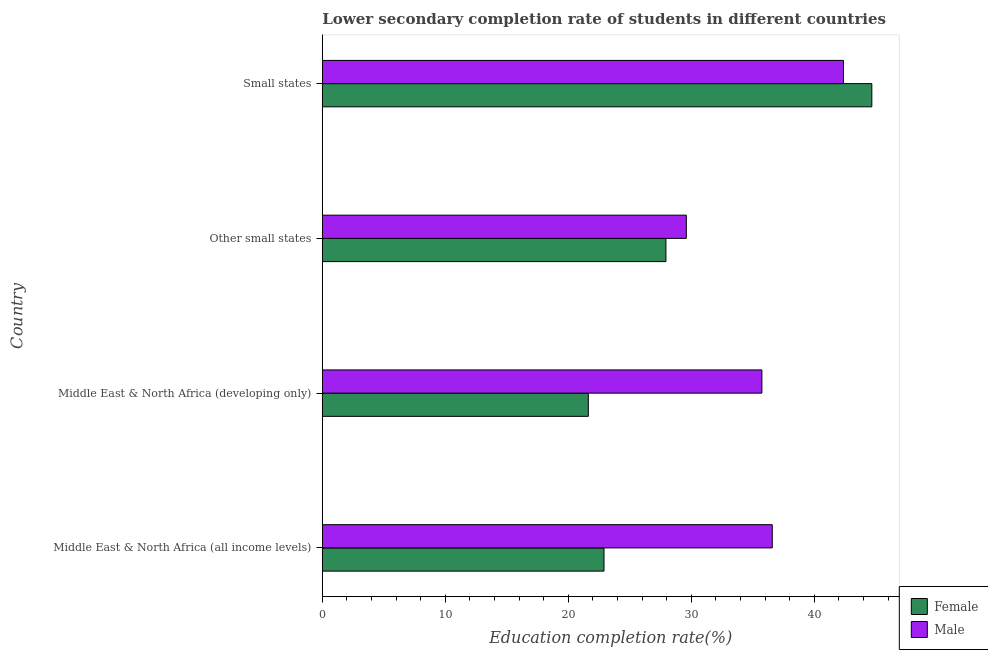Are the number of bars per tick equal to the number of legend labels?
Provide a succinct answer. Yes. How many bars are there on the 2nd tick from the top?
Provide a succinct answer. 2. How many bars are there on the 3rd tick from the bottom?
Your response must be concise. 2. What is the label of the 3rd group of bars from the top?
Keep it short and to the point. Middle East & North Africa (developing only). In how many cases, is the number of bars for a given country not equal to the number of legend labels?
Offer a terse response. 0. What is the education completion rate of male students in Middle East & North Africa (developing only)?
Make the answer very short. 35.74. Across all countries, what is the maximum education completion rate of male students?
Your answer should be very brief. 42.37. Across all countries, what is the minimum education completion rate of female students?
Offer a terse response. 21.63. In which country was the education completion rate of female students maximum?
Keep it short and to the point. Small states. In which country was the education completion rate of female students minimum?
Your answer should be compact. Middle East & North Africa (developing only). What is the total education completion rate of female students in the graph?
Your response must be concise. 117.14. What is the difference between the education completion rate of male students in Middle East & North Africa (developing only) and that in Other small states?
Ensure brevity in your answer.  6.14. What is the difference between the education completion rate of female students in Middle East & North Africa (developing only) and the education completion rate of male students in Other small states?
Your answer should be very brief. -7.97. What is the average education completion rate of male students per country?
Your response must be concise. 36.07. What is the difference between the education completion rate of female students and education completion rate of male students in Small states?
Provide a short and direct response. 2.31. In how many countries, is the education completion rate of male students greater than 44 %?
Ensure brevity in your answer.  0. What is the ratio of the education completion rate of male students in Middle East & North Africa (developing only) to that in Small states?
Your answer should be very brief. 0.84. Is the education completion rate of female students in Middle East & North Africa (developing only) less than that in Other small states?
Your answer should be very brief. Yes. What is the difference between the highest and the second highest education completion rate of female students?
Make the answer very short. 16.74. What is the difference between the highest and the lowest education completion rate of female students?
Keep it short and to the point. 23.05. In how many countries, is the education completion rate of male students greater than the average education completion rate of male students taken over all countries?
Ensure brevity in your answer.  2. Is the sum of the education completion rate of male students in Other small states and Small states greater than the maximum education completion rate of female students across all countries?
Make the answer very short. Yes. Are all the bars in the graph horizontal?
Provide a short and direct response. Yes. What is the difference between two consecutive major ticks on the X-axis?
Your answer should be compact. 10. Are the values on the major ticks of X-axis written in scientific E-notation?
Your answer should be compact. No. Where does the legend appear in the graph?
Give a very brief answer. Bottom right. What is the title of the graph?
Offer a terse response. Lower secondary completion rate of students in different countries. Does "Foreign liabilities" appear as one of the legend labels in the graph?
Keep it short and to the point. No. What is the label or title of the X-axis?
Provide a succinct answer. Education completion rate(%). What is the label or title of the Y-axis?
Offer a very short reply. Country. What is the Education completion rate(%) in Female in Middle East & North Africa (all income levels)?
Keep it short and to the point. 22.9. What is the Education completion rate(%) of Male in Middle East & North Africa (all income levels)?
Offer a very short reply. 36.58. What is the Education completion rate(%) in Female in Middle East & North Africa (developing only)?
Provide a short and direct response. 21.63. What is the Education completion rate(%) in Male in Middle East & North Africa (developing only)?
Offer a terse response. 35.74. What is the Education completion rate(%) in Female in Other small states?
Provide a succinct answer. 27.94. What is the Education completion rate(%) of Male in Other small states?
Offer a very short reply. 29.6. What is the Education completion rate(%) in Female in Small states?
Offer a very short reply. 44.68. What is the Education completion rate(%) of Male in Small states?
Your answer should be compact. 42.37. Across all countries, what is the maximum Education completion rate(%) of Female?
Offer a terse response. 44.68. Across all countries, what is the maximum Education completion rate(%) in Male?
Offer a terse response. 42.37. Across all countries, what is the minimum Education completion rate(%) of Female?
Your answer should be very brief. 21.63. Across all countries, what is the minimum Education completion rate(%) of Male?
Offer a terse response. 29.6. What is the total Education completion rate(%) of Female in the graph?
Your answer should be very brief. 117.14. What is the total Education completion rate(%) of Male in the graph?
Make the answer very short. 144.29. What is the difference between the Education completion rate(%) of Female in Middle East & North Africa (all income levels) and that in Middle East & North Africa (developing only)?
Make the answer very short. 1.28. What is the difference between the Education completion rate(%) in Male in Middle East & North Africa (all income levels) and that in Middle East & North Africa (developing only)?
Your response must be concise. 0.84. What is the difference between the Education completion rate(%) in Female in Middle East & North Africa (all income levels) and that in Other small states?
Your answer should be compact. -5.03. What is the difference between the Education completion rate(%) of Male in Middle East & North Africa (all income levels) and that in Other small states?
Your answer should be very brief. 6.99. What is the difference between the Education completion rate(%) of Female in Middle East & North Africa (all income levels) and that in Small states?
Your answer should be very brief. -21.77. What is the difference between the Education completion rate(%) of Male in Middle East & North Africa (all income levels) and that in Small states?
Make the answer very short. -5.79. What is the difference between the Education completion rate(%) in Female in Middle East & North Africa (developing only) and that in Other small states?
Your answer should be very brief. -6.31. What is the difference between the Education completion rate(%) in Male in Middle East & North Africa (developing only) and that in Other small states?
Offer a terse response. 6.14. What is the difference between the Education completion rate(%) in Female in Middle East & North Africa (developing only) and that in Small states?
Ensure brevity in your answer.  -23.05. What is the difference between the Education completion rate(%) in Male in Middle East & North Africa (developing only) and that in Small states?
Offer a very short reply. -6.63. What is the difference between the Education completion rate(%) of Female in Other small states and that in Small states?
Your answer should be compact. -16.74. What is the difference between the Education completion rate(%) in Male in Other small states and that in Small states?
Provide a succinct answer. -12.77. What is the difference between the Education completion rate(%) of Female in Middle East & North Africa (all income levels) and the Education completion rate(%) of Male in Middle East & North Africa (developing only)?
Provide a succinct answer. -12.84. What is the difference between the Education completion rate(%) in Female in Middle East & North Africa (all income levels) and the Education completion rate(%) in Male in Other small states?
Provide a succinct answer. -6.69. What is the difference between the Education completion rate(%) in Female in Middle East & North Africa (all income levels) and the Education completion rate(%) in Male in Small states?
Provide a succinct answer. -19.47. What is the difference between the Education completion rate(%) in Female in Middle East & North Africa (developing only) and the Education completion rate(%) in Male in Other small states?
Your answer should be very brief. -7.97. What is the difference between the Education completion rate(%) of Female in Middle East & North Africa (developing only) and the Education completion rate(%) of Male in Small states?
Provide a succinct answer. -20.74. What is the difference between the Education completion rate(%) in Female in Other small states and the Education completion rate(%) in Male in Small states?
Make the answer very short. -14.43. What is the average Education completion rate(%) in Female per country?
Your answer should be very brief. 29.28. What is the average Education completion rate(%) in Male per country?
Offer a very short reply. 36.07. What is the difference between the Education completion rate(%) of Female and Education completion rate(%) of Male in Middle East & North Africa (all income levels)?
Keep it short and to the point. -13.68. What is the difference between the Education completion rate(%) of Female and Education completion rate(%) of Male in Middle East & North Africa (developing only)?
Provide a succinct answer. -14.11. What is the difference between the Education completion rate(%) of Female and Education completion rate(%) of Male in Other small states?
Make the answer very short. -1.66. What is the difference between the Education completion rate(%) in Female and Education completion rate(%) in Male in Small states?
Your response must be concise. 2.31. What is the ratio of the Education completion rate(%) of Female in Middle East & North Africa (all income levels) to that in Middle East & North Africa (developing only)?
Provide a succinct answer. 1.06. What is the ratio of the Education completion rate(%) of Male in Middle East & North Africa (all income levels) to that in Middle East & North Africa (developing only)?
Provide a short and direct response. 1.02. What is the ratio of the Education completion rate(%) of Female in Middle East & North Africa (all income levels) to that in Other small states?
Offer a very short reply. 0.82. What is the ratio of the Education completion rate(%) in Male in Middle East & North Africa (all income levels) to that in Other small states?
Keep it short and to the point. 1.24. What is the ratio of the Education completion rate(%) of Female in Middle East & North Africa (all income levels) to that in Small states?
Offer a very short reply. 0.51. What is the ratio of the Education completion rate(%) of Male in Middle East & North Africa (all income levels) to that in Small states?
Offer a terse response. 0.86. What is the ratio of the Education completion rate(%) in Female in Middle East & North Africa (developing only) to that in Other small states?
Your answer should be very brief. 0.77. What is the ratio of the Education completion rate(%) in Male in Middle East & North Africa (developing only) to that in Other small states?
Keep it short and to the point. 1.21. What is the ratio of the Education completion rate(%) of Female in Middle East & North Africa (developing only) to that in Small states?
Keep it short and to the point. 0.48. What is the ratio of the Education completion rate(%) of Male in Middle East & North Africa (developing only) to that in Small states?
Your answer should be compact. 0.84. What is the ratio of the Education completion rate(%) in Female in Other small states to that in Small states?
Offer a terse response. 0.63. What is the ratio of the Education completion rate(%) in Male in Other small states to that in Small states?
Your response must be concise. 0.7. What is the difference between the highest and the second highest Education completion rate(%) in Female?
Offer a very short reply. 16.74. What is the difference between the highest and the second highest Education completion rate(%) in Male?
Provide a short and direct response. 5.79. What is the difference between the highest and the lowest Education completion rate(%) in Female?
Your response must be concise. 23.05. What is the difference between the highest and the lowest Education completion rate(%) in Male?
Your response must be concise. 12.77. 